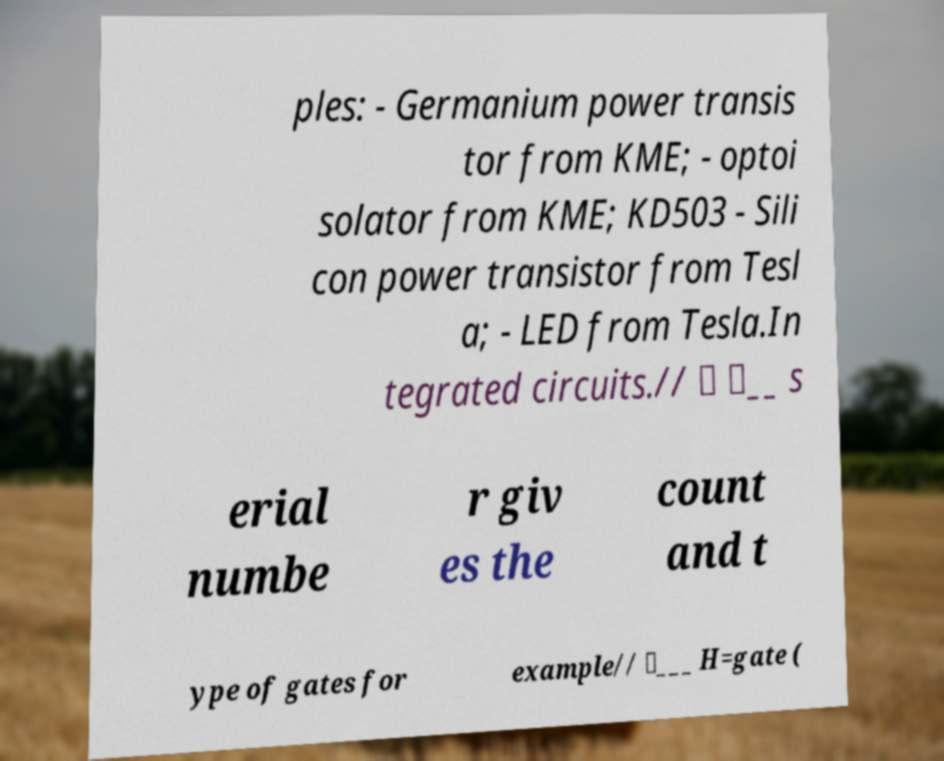For documentation purposes, I need the text within this image transcribed. Could you provide that? ples: - Germanium power transis tor from KME; - optoi solator from KME; KD503 - Sili con power transistor from Tesl a; - LED from Tesla.In tegrated circuits.// \ \__ s erial numbe r giv es the count and t ype of gates for example// \___ H=gate ( 